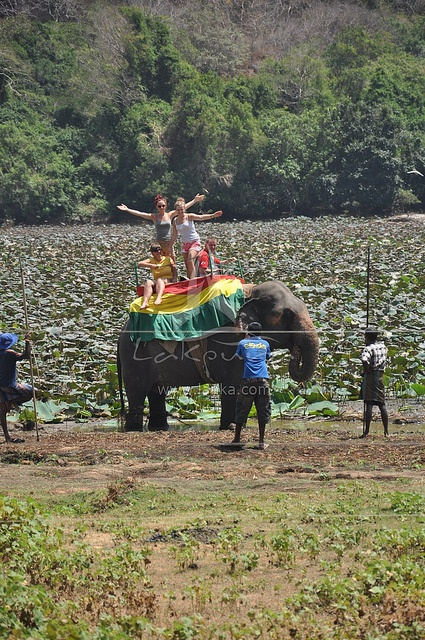Describe the objects in this image and their specific colors. I can see elephant in black, gray, and darkgray tones, people in black, gray, lightblue, and navy tones, people in black, gray, lightgray, and darkgray tones, people in black, gray, navy, and darkgray tones, and people in black, olive, maroon, and gray tones in this image. 